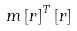Convert formula to latex. <formula><loc_0><loc_0><loc_500><loc_500>m \left [ r \right ] ^ { T } \left [ r \right ]</formula> 